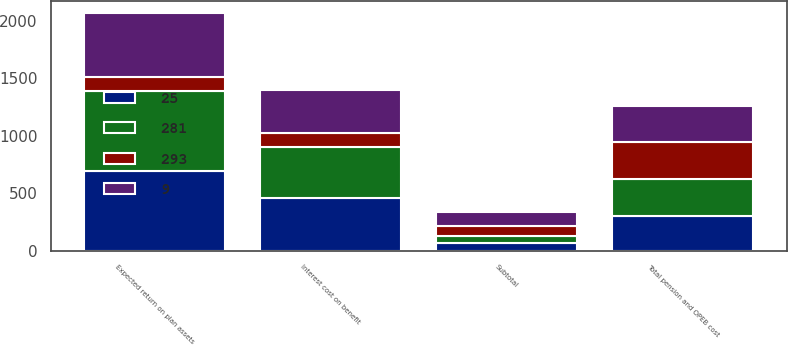Convert chart. <chart><loc_0><loc_0><loc_500><loc_500><stacked_bar_chart><ecel><fcel>Interest cost on benefit<fcel>Expected return on plan assets<fcel>Subtotal<fcel>Total pension and OPEB cost<nl><fcel>281<fcel>452<fcel>692<fcel>60<fcel>316<nl><fcel>25<fcel>453<fcel>694<fcel>64<fcel>304<nl><fcel>9<fcel>368<fcel>556<fcel>129<fcel>317<nl><fcel>293<fcel>120<fcel>122<fcel>86<fcel>321<nl></chart> 